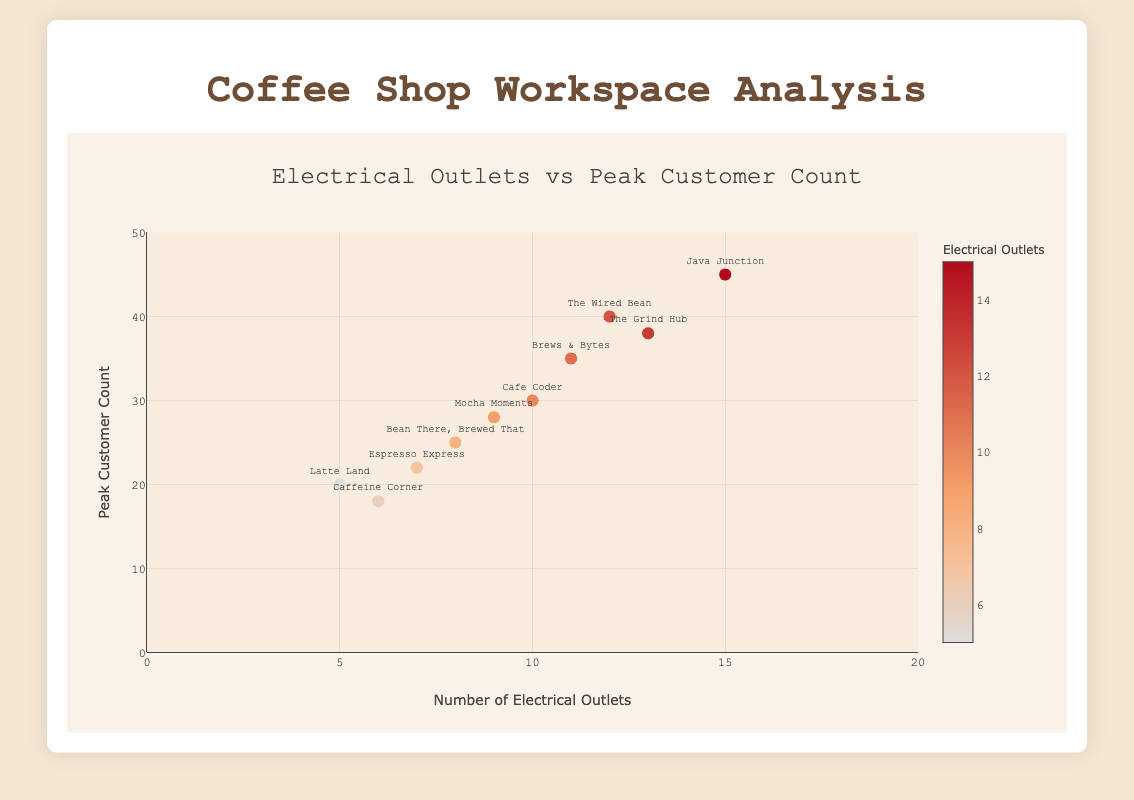What is the title of the Scatter Plot? The title is prominently displayed at the top of the plot in a larger and bold font.
Answer: Electrical Outlets vs Peak Customer Count How many coffee shops have 10 or more electrical outlets? Count the number of data points (markers) where the x-axis value (number of electrical outlets) is 10 or higher.
Answer: 5 Which coffee shop has the highest peak customer count? Find the highest point on the y-axis, then identify the associated coffee shop from the text labels near the markers.
Answer: Java Junction How many coffee shops have a peak customer count below 30? Count the number of data points (markers) where the y-axis value (peak customer count) is less than 30.
Answer: 4 What is the name of the coffee shop with 13 electrical outlets? Locate the marker where the x-axis value is 13, and identify the text label associated with it.
Answer: The Grind Hub Which coffee shops have an equal number of electrical outlets but different peak customer counts? Find pairs of markers that have the same x-axis value (number of electrical outlets) but different y-axis values (peak customer counts).
Answer: Espresso Express and Latte Land What is the average number of electrical outlets among all coffee shops? Sum all the x-axis values (number of electrical outlets) and divide by the number of data points, which is 10 in this case. (12 + 8 + 15 + 10 + 5 + 7 + 9 + 11 + 6 + 13) / 10 = 96 / 10 = 9.6
Answer: 9.6 Which coffee shop has the highest ratio of electrical outlets to peak customer count? Calculate the ratio (number of electrical outlets / peak customer count) for each coffee shop and identify the highest one. Java Junction: 15/45 = 0.33, The Grind Hub: 13/38 = 0.34, and others. The highest is Caffeine Corner: 6 / 18 = 0.33.
Answer: Caffeine Corner Is there a visible trend between the number of electrical outlets and the peak customer count? Look at the general direction of the markers' spread on the plot. A positive trend would show higher values of one metric associated with higher values of the other. While there's a moderately positive trend, it's clear by observation.
Answer: Yes, moderate positive trend Which coffee shop is closest to having an equal number of electrical outlets and peak customer count? Compare the x and y values of each marker and find the smallest difference.
Answer: The Wired Bean (12 outlets and 40 customers) 